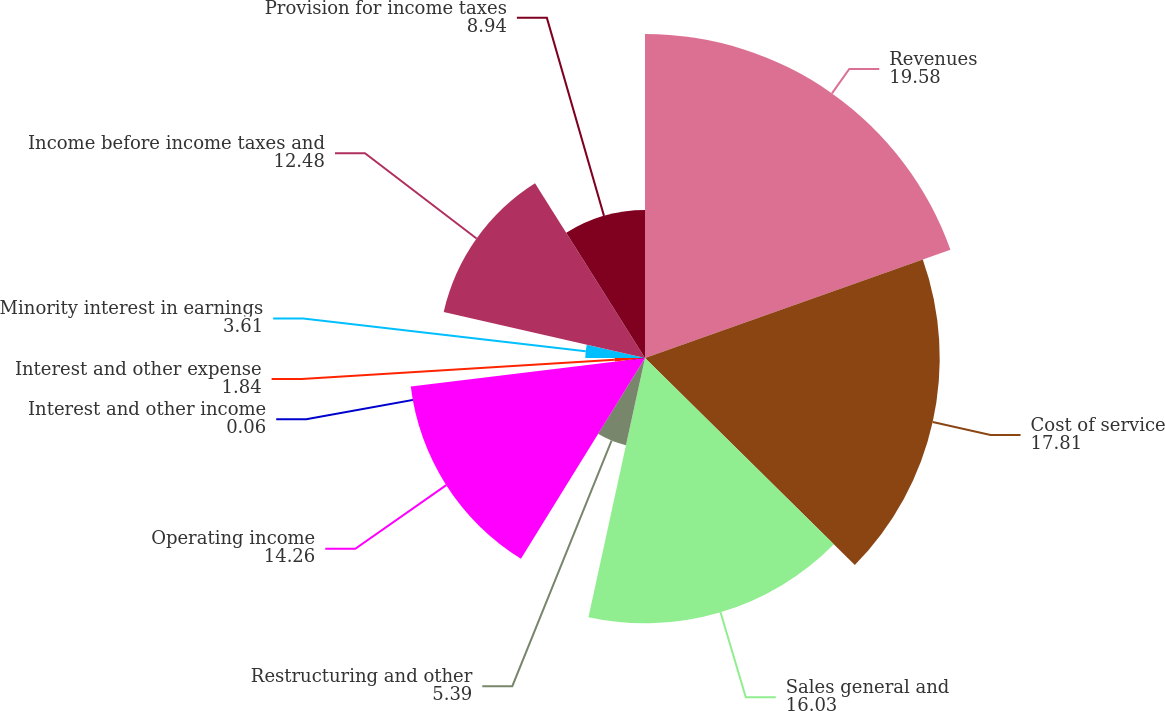Convert chart to OTSL. <chart><loc_0><loc_0><loc_500><loc_500><pie_chart><fcel>Revenues<fcel>Cost of service<fcel>Sales general and<fcel>Restructuring and other<fcel>Operating income<fcel>Interest and other income<fcel>Interest and other expense<fcel>Minority interest in earnings<fcel>Income before income taxes and<fcel>Provision for income taxes<nl><fcel>19.58%<fcel>17.81%<fcel>16.03%<fcel>5.39%<fcel>14.26%<fcel>0.06%<fcel>1.84%<fcel>3.61%<fcel>12.48%<fcel>8.94%<nl></chart> 